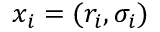<formula> <loc_0><loc_0><loc_500><loc_500>x _ { i } = ( r _ { i } , \sigma _ { i } )</formula> 